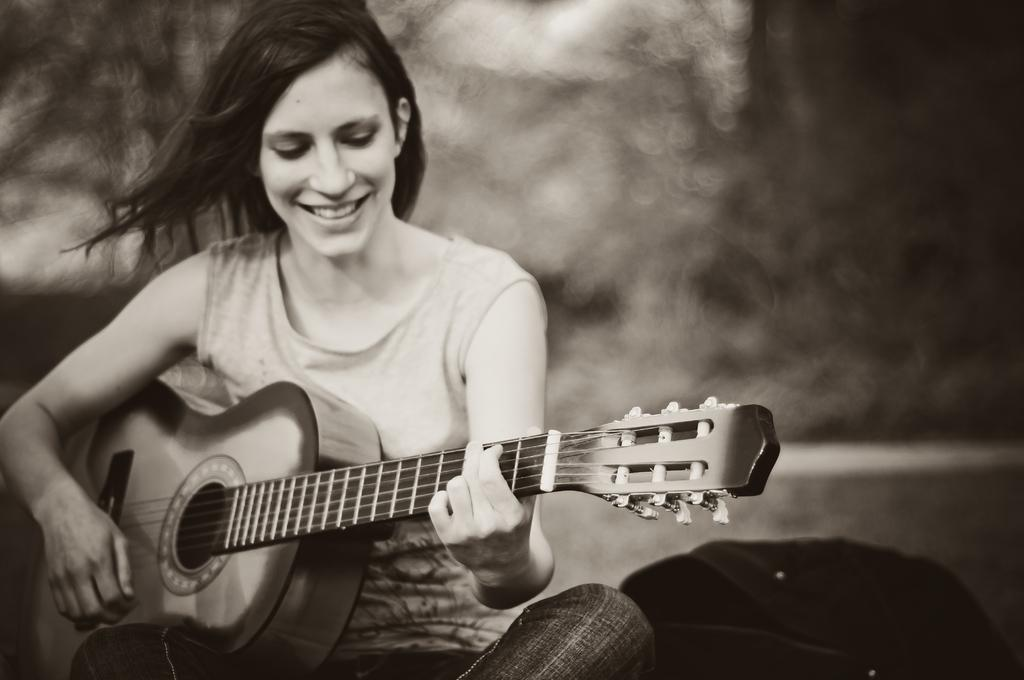Who is the main subject in the image? There is a woman in the image. What is the woman doing in the image? The woman is sitting and playing a guitar. What is the woman's facial expression in the image? The woman is smiling in the image. What object is beside the woman in the image? There is a bag beside the woman in the image. How does the woman distribute the stone in the image? There is no stone present in the image, so the woman cannot distribute it. 